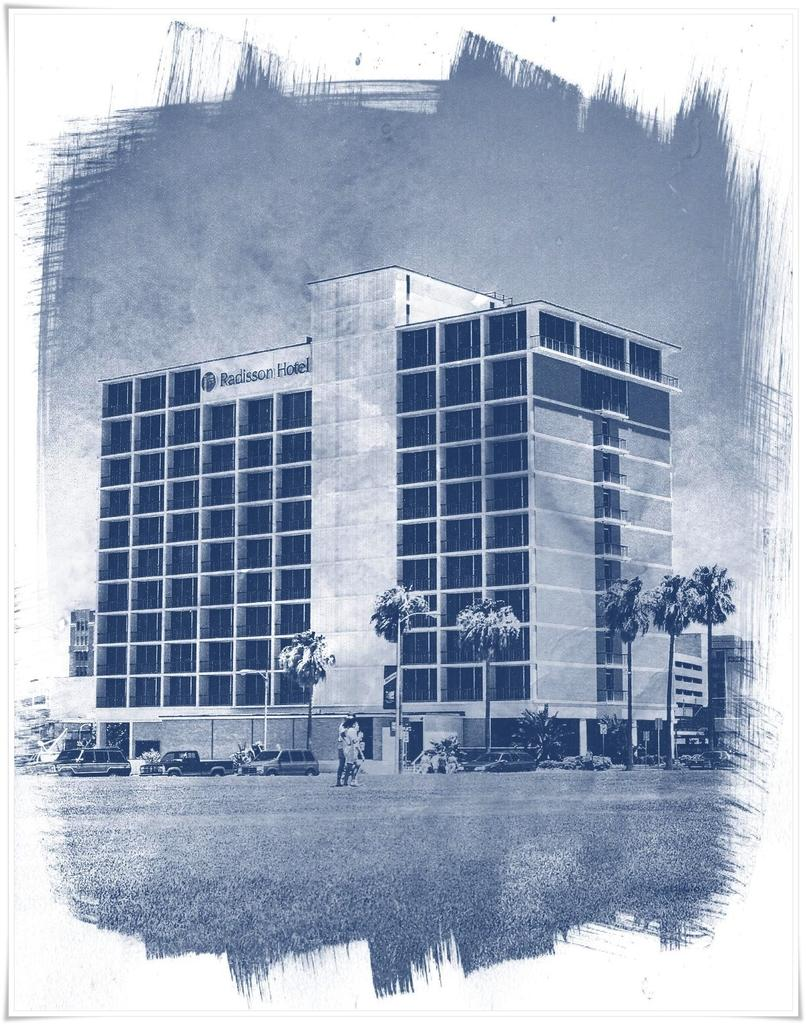What type of drawing is the image? The image is a sketch. What is depicted in the sketch? There is a building, trees, vehicles, boards, poles, and people in the sketch. Can you describe the building in the sketch? The building has text on it. What is visible at the bottom of the sketch? The ground is visible at the bottom of the sketch. How many types of objects can be seen on the ground in the sketch? There are vehicles and people on the ground in the sketch. How many smiles can be seen on the people in the sketch? There are no smiles visible on the people in the sketch, as it is a drawing and not a photograph. What type of knot is tied around the pole in the sketch? There is no knot present around the poles in the sketch. 